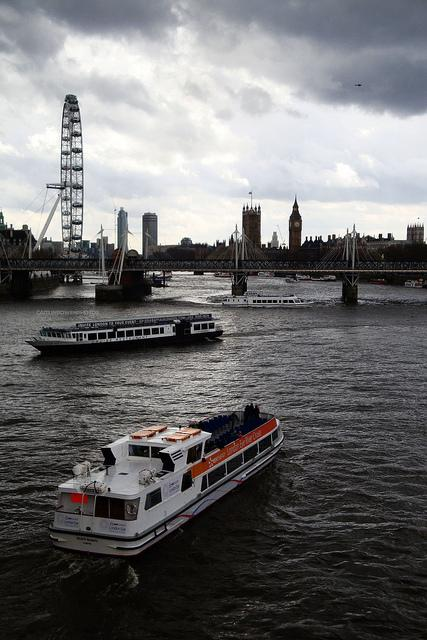What problem will the people on the ferry face?

Choices:
A) earthquake
B) raining
C) sunburn
D) tsunami raining 